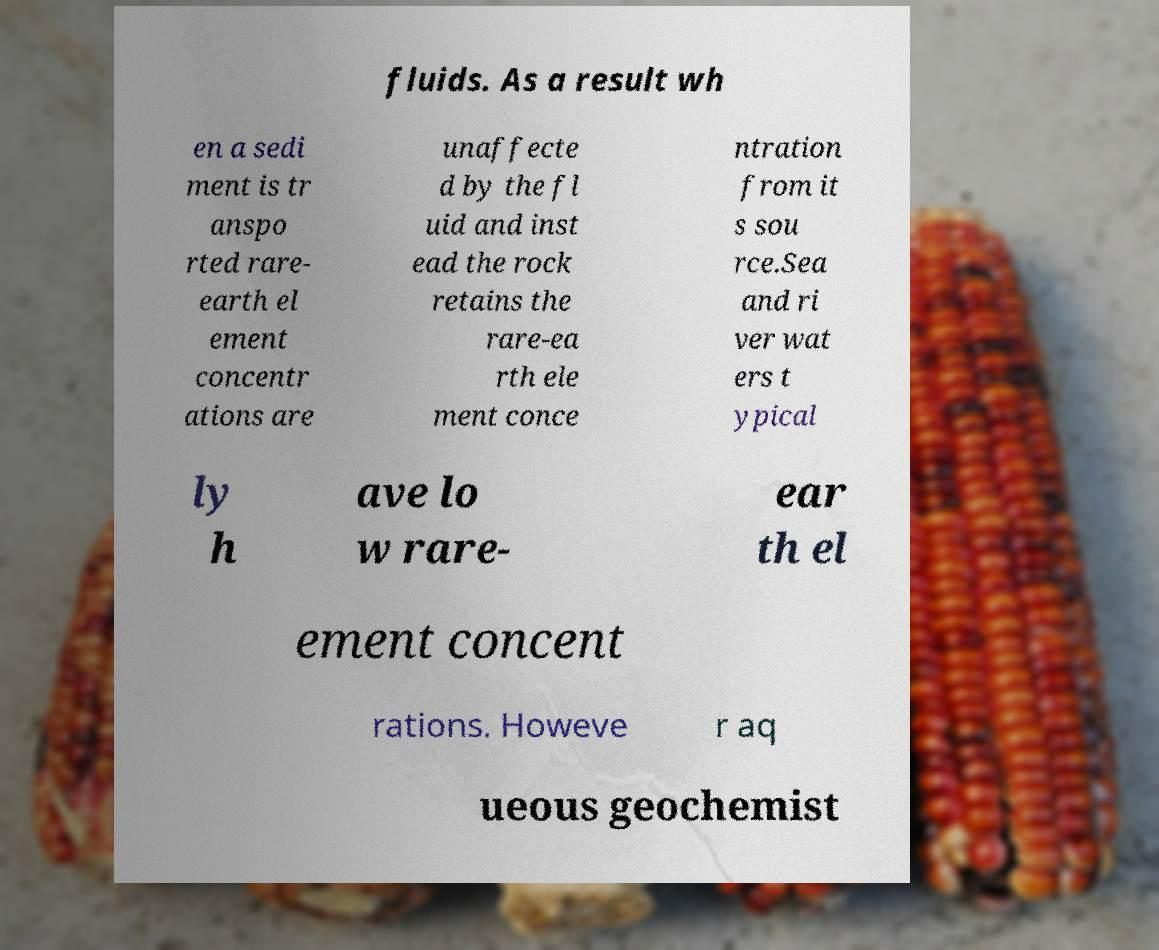For documentation purposes, I need the text within this image transcribed. Could you provide that? fluids. As a result wh en a sedi ment is tr anspo rted rare- earth el ement concentr ations are unaffecte d by the fl uid and inst ead the rock retains the rare-ea rth ele ment conce ntration from it s sou rce.Sea and ri ver wat ers t ypical ly h ave lo w rare- ear th el ement concent rations. Howeve r aq ueous geochemist 